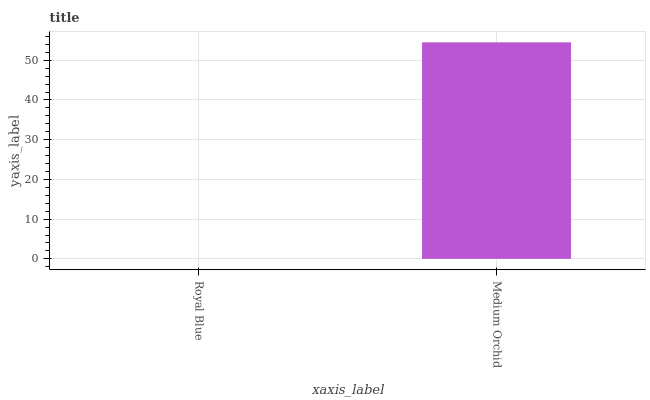Is Medium Orchid the minimum?
Answer yes or no. No. Is Medium Orchid greater than Royal Blue?
Answer yes or no. Yes. Is Royal Blue less than Medium Orchid?
Answer yes or no. Yes. Is Royal Blue greater than Medium Orchid?
Answer yes or no. No. Is Medium Orchid less than Royal Blue?
Answer yes or no. No. Is Medium Orchid the high median?
Answer yes or no. Yes. Is Royal Blue the low median?
Answer yes or no. Yes. Is Royal Blue the high median?
Answer yes or no. No. Is Medium Orchid the low median?
Answer yes or no. No. 